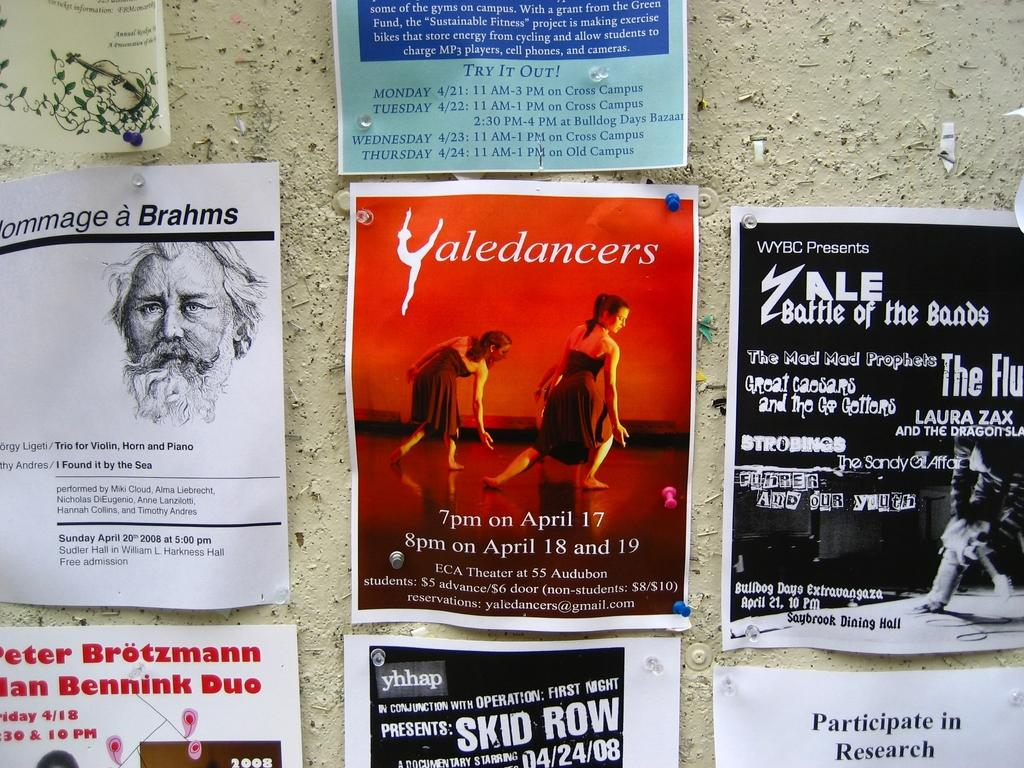<image>
Render a clear and concise summary of the photo. Many fliers are on a bulletin board, including an advertisement for Yaledancers. 